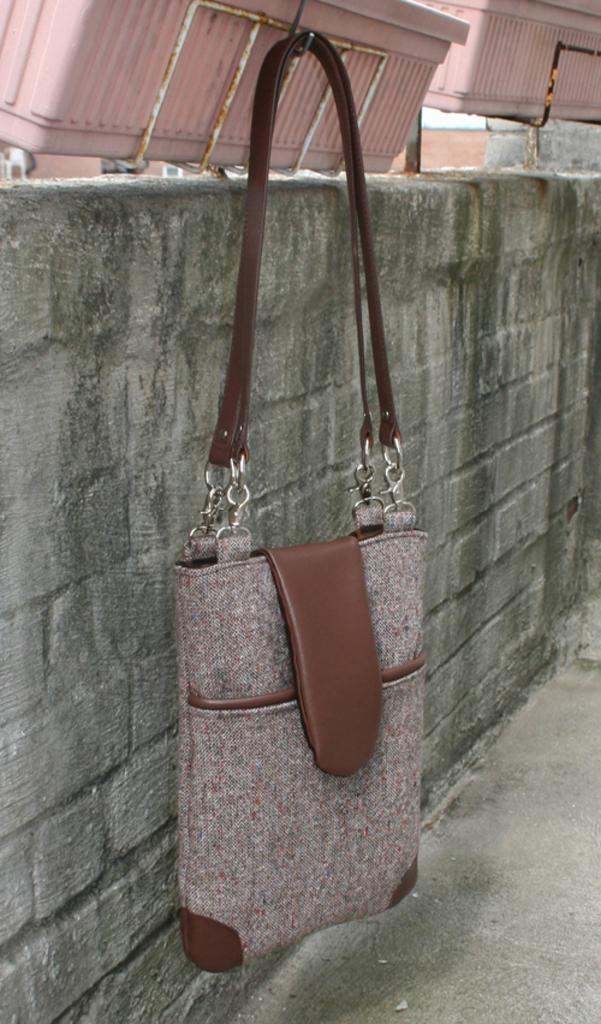What object is hanging in the image? There is a bag hanging in the image. What can be seen in the background of the image? There is a wall visible in the background of the image. What type of learning is taking place in the image? There is no indication of any learning taking place in the image. How does the wave interact with the bag in the image? There is no wave present in the image; it only features a hanging bag and a wall in the background. 